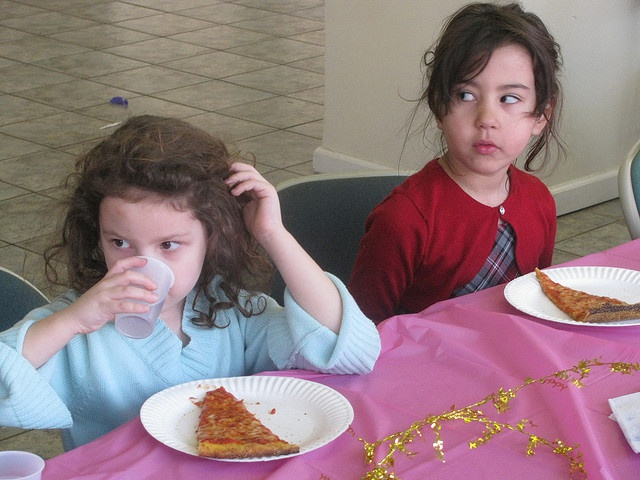Describe the objects in this image and their specific colors. I can see dining table in gray, violet, lightgray, and brown tones, people in gray, lightblue, black, and lavender tones, people in gray, maroon, black, brown, and lightpink tones, chair in gray, black, darkgray, and purple tones, and pizza in gray, brown, and tan tones in this image. 